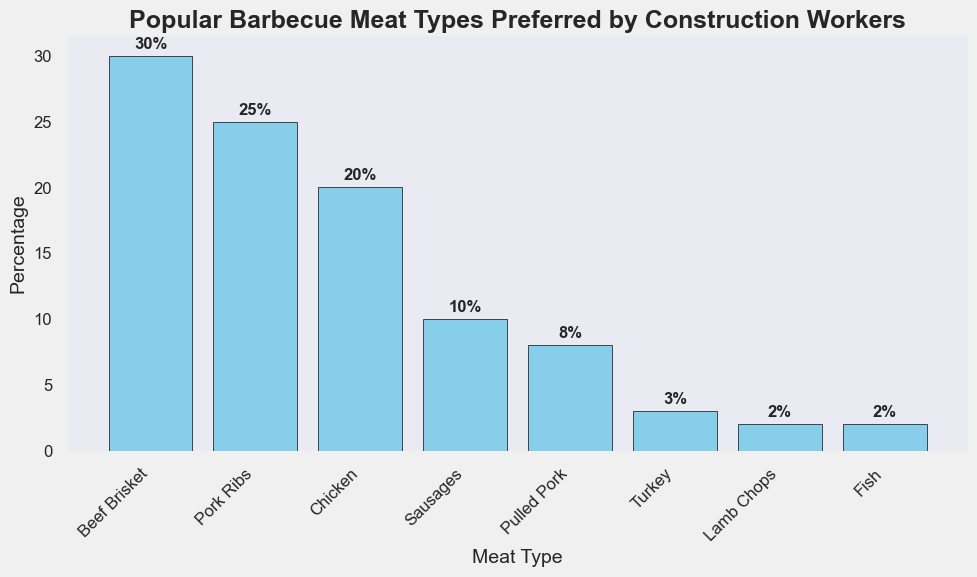What is the most preferred barbecue meat type among construction workers? The tallest bar represents the most preferred barbecue meat type. It corresponds to Beef Brisket.
Answer: Beef Brisket Which is preferred more, Pork Ribs or Sausages? By comparing the heights of the bars, the bar for Pork Ribs is taller than the bar for Sausages, indicating that Pork Ribs are preferred more.
Answer: Pork Ribs What is the combined percentage of Chicken and Pulled Pork preferences? The percentages for Chicken and Pulled Pork are 20% and 8%, respectively. Adding these together gives 20% + 8% = 28%.
Answer: 28% How much more popular is Beef Brisket than Turkey? The percentage for Beef Brisket is 30% and for Turkey is 3%. Subtracting these gives 30% - 3% = 27%.
Answer: 27% Is Fish preference higher than Lamb Chops? Both Fish and Lamb Chops have bars of the same height, indicating they are equally preferred.
Answer: No Which barbecue meat type is the least preferred? The shortest bars indicate the least preferred types. Both Lamb Chops and Fish have an equal percentage of 2%, making them the least preferred.
Answer: Lamb Chops and Fish How many meat types have a preference of 10% or higher? The meat types with percentages of 10% or higher are Beef Brisket (30%), Pork Ribs (25%), Chicken (20%), and Sausages (10%). Counting these, we have 4 types.
Answer: 4 What is the percentage difference between the second and third most preferred meat types? The second most preferred is Pork Ribs at 25%, and the third most preferred is Chicken at 20%. The difference is 25% - 20% = 5%.
Answer: 5% How does the preference for Pulled Pork compare to that for Sausages? Pulled Pork has a percentage of 8% and Sausages 10%. Since 8% is less than 10%, Pulled Pork is less preferred than Sausages.
Answer: Pulled Pork is less preferred 